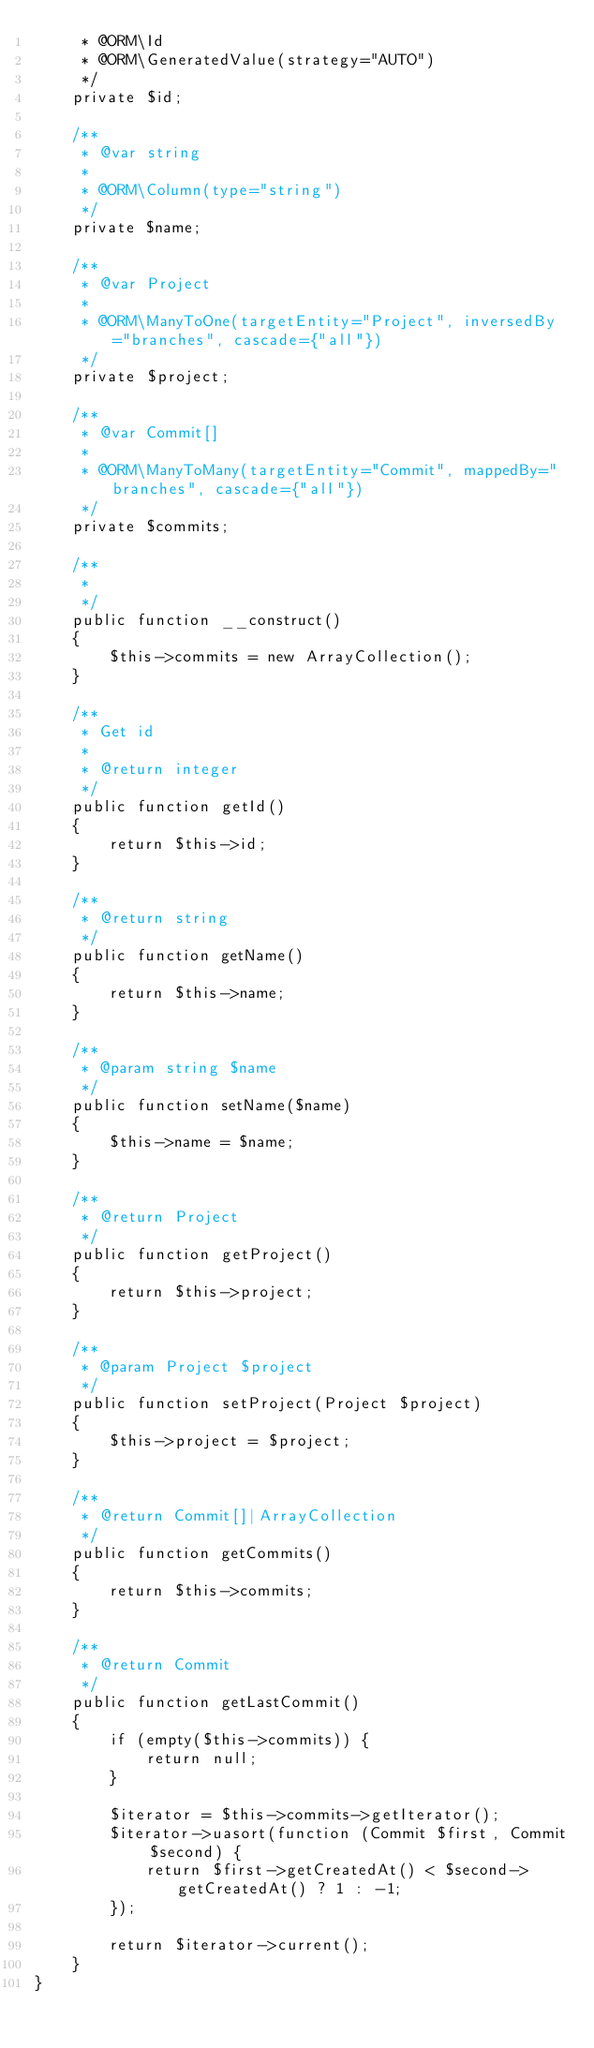<code> <loc_0><loc_0><loc_500><loc_500><_PHP_>     * @ORM\Id
     * @ORM\GeneratedValue(strategy="AUTO")
     */
    private $id;

    /**
     * @var string
     *
     * @ORM\Column(type="string")
     */
    private $name;

    /**
     * @var Project
     *
     * @ORM\ManyToOne(targetEntity="Project", inversedBy="branches", cascade={"all"})
     */
    private $project;

    /**
     * @var Commit[]
     *
     * @ORM\ManyToMany(targetEntity="Commit", mappedBy="branches", cascade={"all"})
     */
    private $commits;

    /**
     *
     */
    public function __construct()
    {
        $this->commits = new ArrayCollection();
    }

    /**
     * Get id
     *
     * @return integer
     */
    public function getId()
    {
        return $this->id;
    }

    /**
     * @return string
     */
    public function getName()
    {
        return $this->name;
    }

    /**
     * @param string $name
     */
    public function setName($name)
    {
        $this->name = $name;
    }

    /**
     * @return Project
     */
    public function getProject()
    {
        return $this->project;
    }

    /**
     * @param Project $project
     */
    public function setProject(Project $project)
    {
        $this->project = $project;
    }

    /**
     * @return Commit[]|ArrayCollection
     */
    public function getCommits()
    {
        return $this->commits;
    }

    /**
     * @return Commit
     */
    public function getLastCommit()
    {
        if (empty($this->commits)) {
            return null;
        }

        $iterator = $this->commits->getIterator();
        $iterator->uasort(function (Commit $first, Commit $second) {
            return $first->getCreatedAt() < $second->getCreatedAt() ? 1 : -1;
        });

        return $iterator->current();
    }
}
</code> 